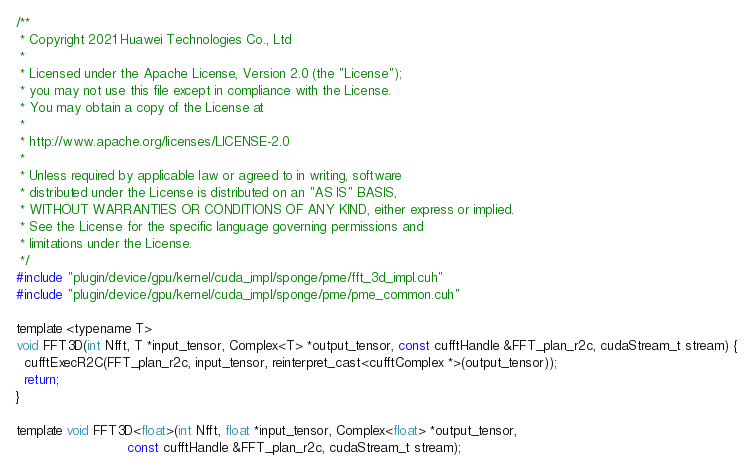<code> <loc_0><loc_0><loc_500><loc_500><_Cuda_>/**
 * Copyright 2021 Huawei Technologies Co., Ltd
 *
 * Licensed under the Apache License, Version 2.0 (the "License");
 * you may not use this file except in compliance with the License.
 * You may obtain a copy of the License at
 *
 * http://www.apache.org/licenses/LICENSE-2.0
 *
 * Unless required by applicable law or agreed to in writing, software
 * distributed under the License is distributed on an "AS IS" BASIS,
 * WITHOUT WARRANTIES OR CONDITIONS OF ANY KIND, either express or implied.
 * See the License for the specific language governing permissions and
 * limitations under the License.
 */
#include "plugin/device/gpu/kernel/cuda_impl/sponge/pme/fft_3d_impl.cuh"
#include "plugin/device/gpu/kernel/cuda_impl/sponge/pme/pme_common.cuh"

template <typename T>
void FFT3D(int Nfft, T *input_tensor, Complex<T> *output_tensor, const cufftHandle &FFT_plan_r2c, cudaStream_t stream) {
  cufftExecR2C(FFT_plan_r2c, input_tensor, reinterpret_cast<cufftComplex *>(output_tensor));
  return;
}

template void FFT3D<float>(int Nfft, float *input_tensor, Complex<float> *output_tensor,
                           const cufftHandle &FFT_plan_r2c, cudaStream_t stream);
</code> 